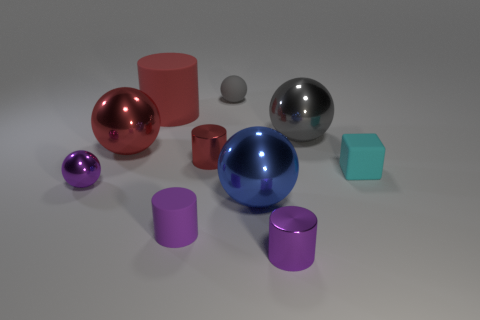Subtract all cylinders. How many objects are left? 6 Subtract all tiny blue metallic things. Subtract all rubber balls. How many objects are left? 9 Add 7 small cylinders. How many small cylinders are left? 10 Add 6 green spheres. How many green spheres exist? 6 Subtract 0 gray cylinders. How many objects are left? 10 